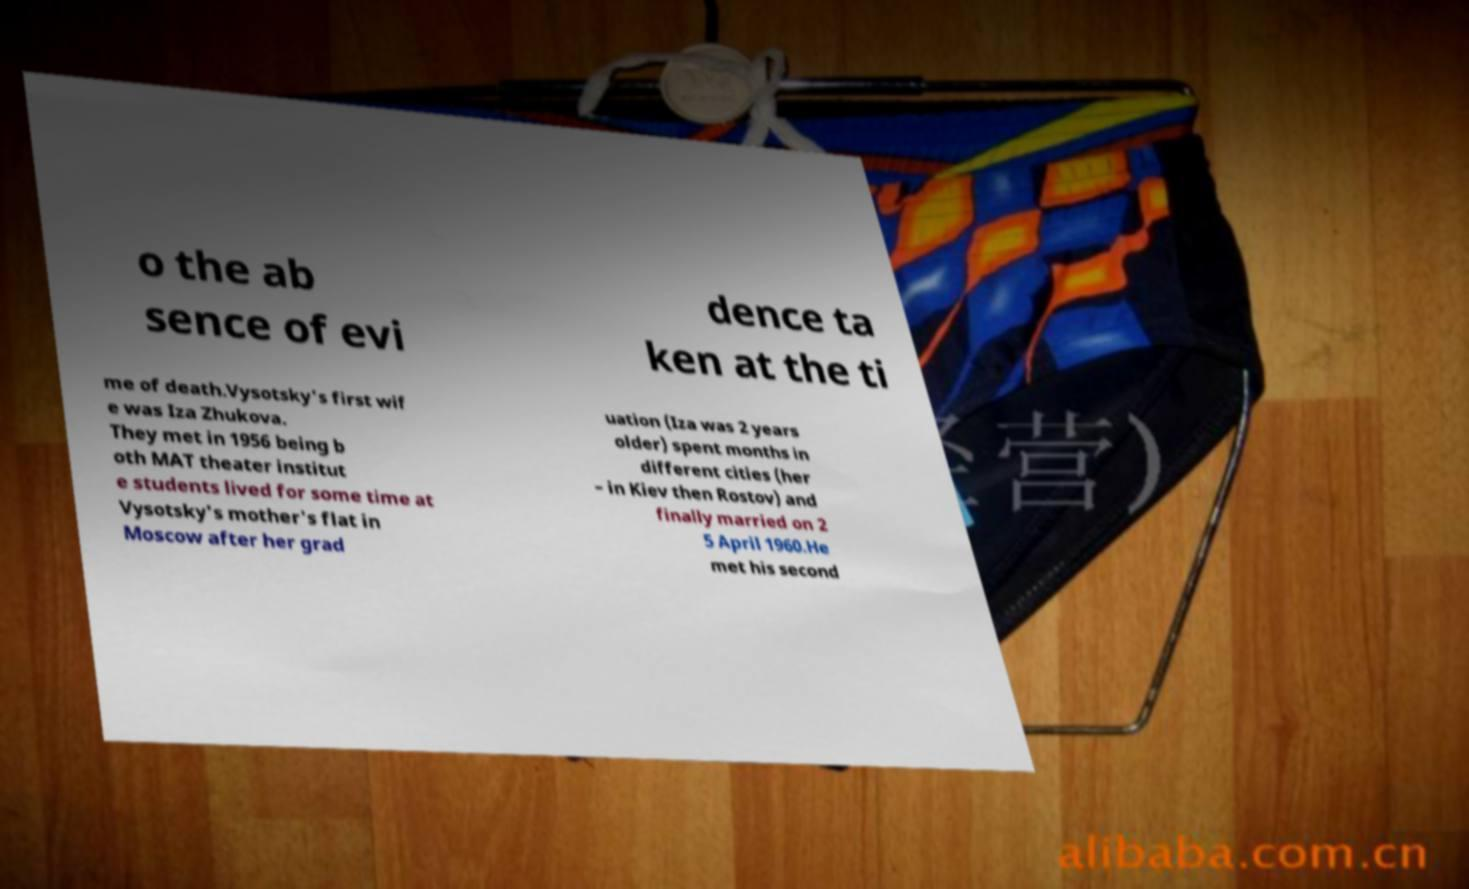There's text embedded in this image that I need extracted. Can you transcribe it verbatim? o the ab sence of evi dence ta ken at the ti me of death.Vysotsky's first wif e was Iza Zhukova. They met in 1956 being b oth MAT theater institut e students lived for some time at Vysotsky's mother's flat in Moscow after her grad uation (Iza was 2 years older) spent months in different cities (her – in Kiev then Rostov) and finally married on 2 5 April 1960.He met his second 